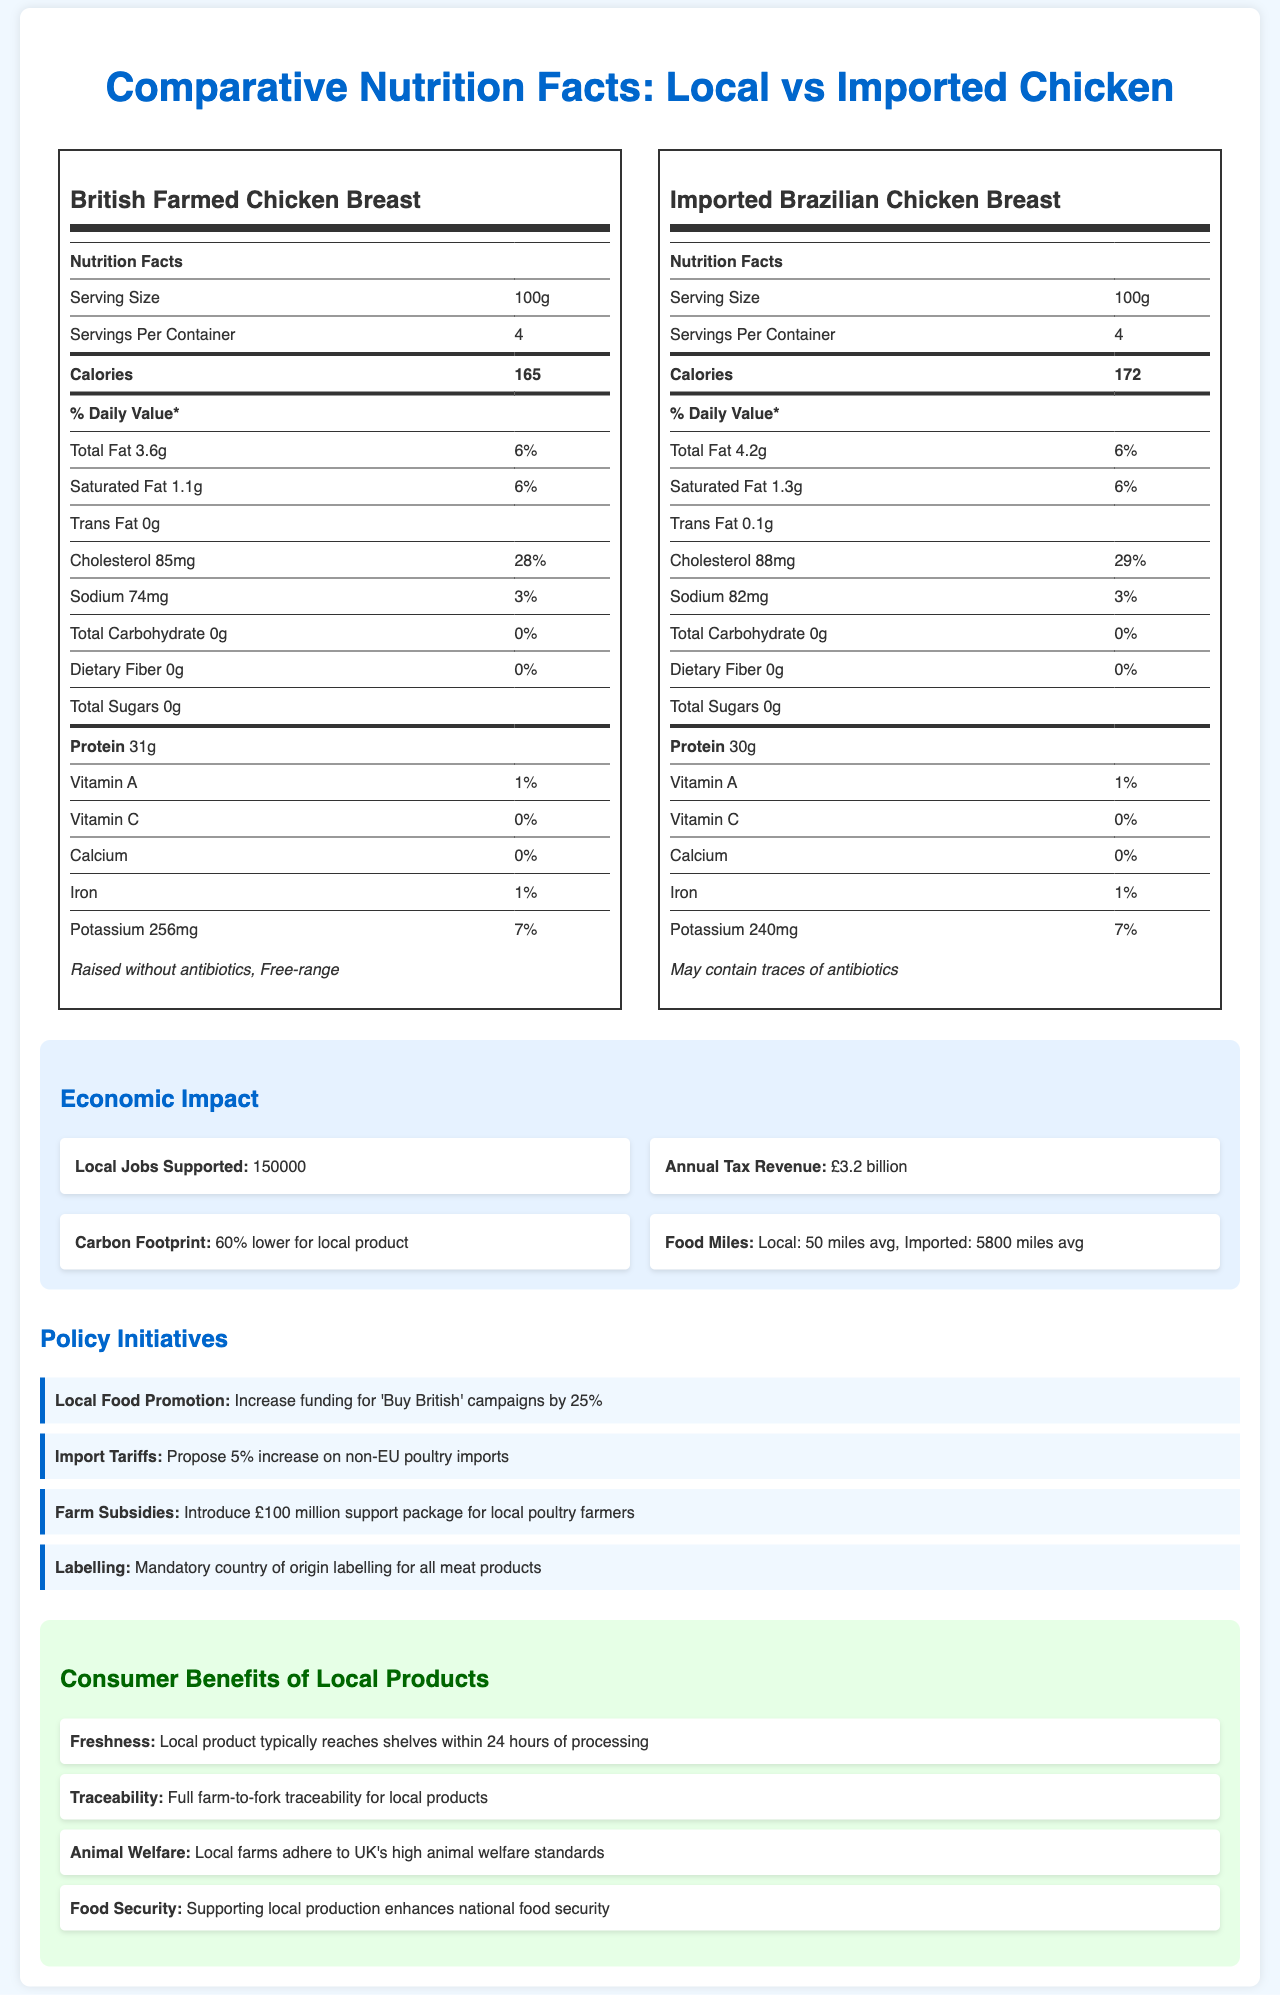what is the serving size for both products? The serving size for both the British Farmed Chicken Breast and the Imported Brazilian Chicken Breast is listed as 100g on their respective nutrition labels.
Answer: 100g how many calories are in one serving of the local product? The nutrition facts label for the British Farmed Chicken Breast shows that one serving contains 165 calories.
Answer: 165 which product has more protein per serving? The nutrition facts label indicates that the British Farmed Chicken Breast has 31g of protein per serving, while the Imported Brazilian Chicken Breast has 30g per serving.
Answer: British Farmed Chicken Breast what additional information is provided about the lower carbon footprint impact? The economic impact section states that the carbon footprint is 60% lower for the local product.
Answer: 60% lower for local product how many food miles does the imported product average compared to the local product? The economic impact section mentions that the local product averages 50 miles, while the imported product averages 5800 miles.
Answer: Local: 50 miles, Imported: 5800 miles which policy initiative aims to increase support for local poultry farmers? A. Local Food Promotion B. Import Tariffs C. Farm Subsidies D. Labelling The policy initiatives section lists "Introduce £100 million support package for local poultry farmers" under Farm Subsidies.
Answer: C. Farm Subsidies what is the percentage daily value of sodium in the imported product? A. 2% B. 3% C. 5% D. 10% The nutrition facts label for the Imported Brazilian Chicken Breast shows 82mg of sodium, and the daily value percentage is 3%.
Answer: B. 3% does the imported product potentially contain antibiotics? The additional info for the Imported Brazilian Chicken Breast states "May contain traces of antibiotics."
Answer: Yes describe the main idea of the document. The document provides a comparative analysis between locally sourced British Farmed Chicken Breast and imported Brazilian Chicken Breast, including their nutrition facts, economic impacts, policy measures to support local products, and the benefits to consumers of buying local products.
Answer: Comparison of local and imported chicken in terms of nutrition, economic impact, policy initiatives, and consumer benefits. what is the exact amount of annual tax revenue generated by the local product? The economic impact section specifies an annual tax revenue of £3.2 billion generated by supporting local products.
Answer: £3.2 billion can you find if the local product supports more jobs than the imported product? The document mentions that the local product supports 150,000 jobs but does not specify the number of jobs supported by the imported product, making it impossible to compare.
Answer: Not enough information do both products have the same amount of iron per serving? Both the British Farmed Chicken Breast and the Imported Brazilian Chicken Breast have 1% of the daily value of iron per serving as listed in their nutrition facts.
Answer: Yes which product has a higher calorie count per serving? A. Local Product B. Imported Product C. Both products have the same calorie count D. None of the above The nutrition facts labels show that the Imported Brazilian Chicken Breast has 172 calories per serving, while the British Farmed Chicken Breast has 165 calories per serving.
Answer: B. Imported Product is the freshness of the local product highlighted in the consumer benefits section? The consumer benefits section states that the local product typically reaches shelves within 24 hours of processing, highlighting its freshness.
Answer: Yes is the sugar content different between the two products? The nutrition facts label for both products shows a total sugar content of 0g per serving.
Answer: No 